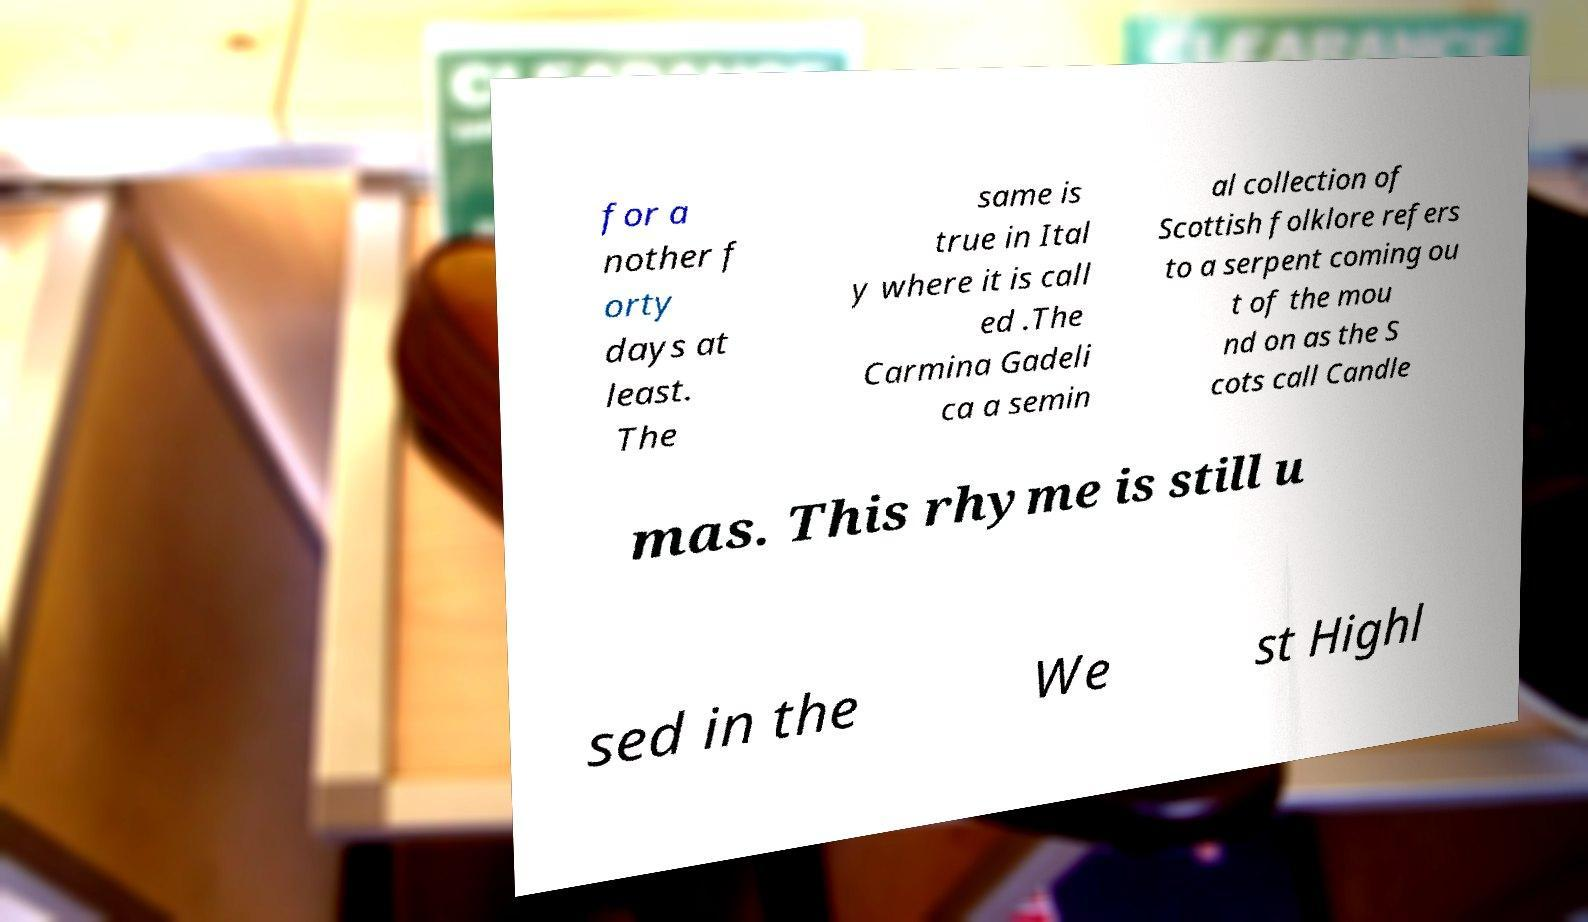There's text embedded in this image that I need extracted. Can you transcribe it verbatim? for a nother f orty days at least. The same is true in Ital y where it is call ed .The Carmina Gadeli ca a semin al collection of Scottish folklore refers to a serpent coming ou t of the mou nd on as the S cots call Candle mas. This rhyme is still u sed in the We st Highl 